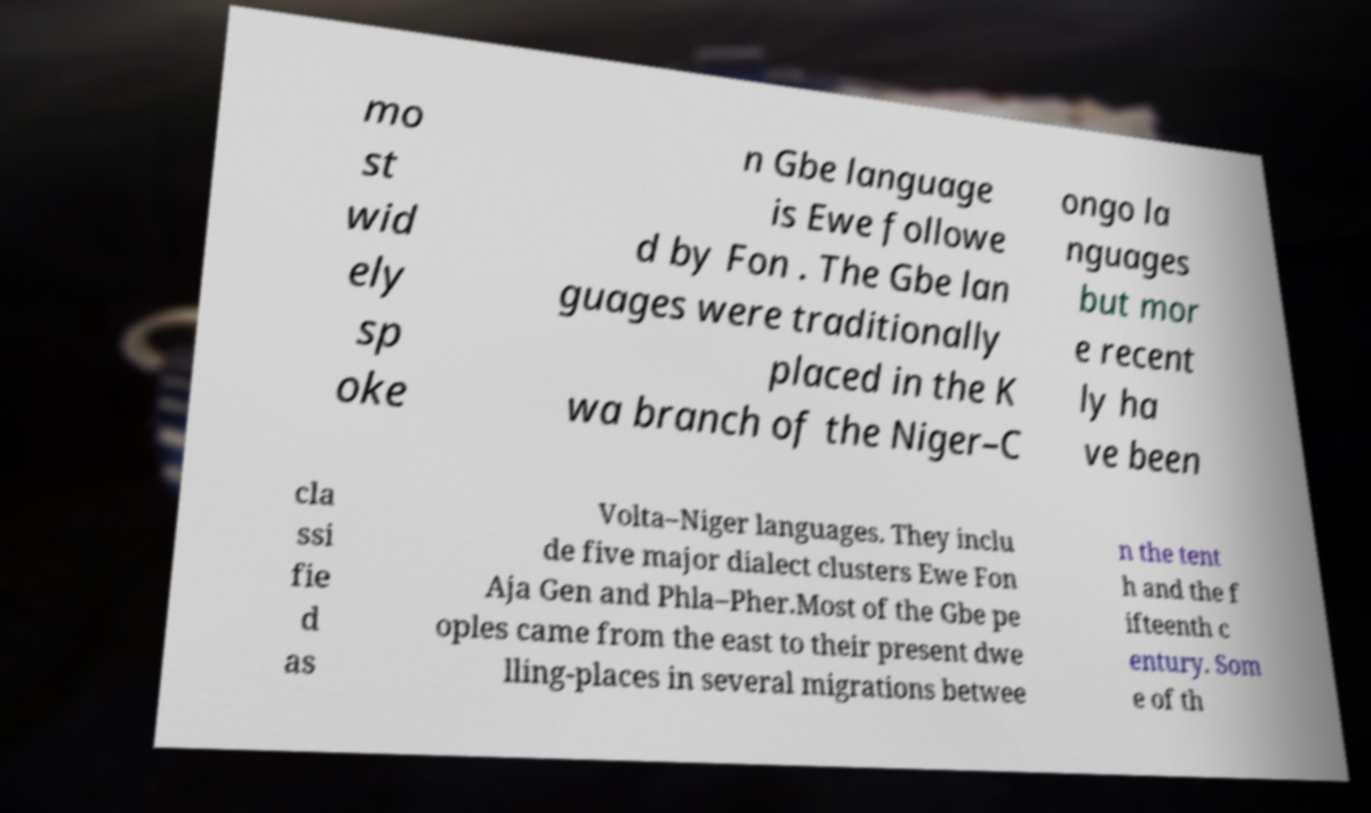What messages or text are displayed in this image? I need them in a readable, typed format. mo st wid ely sp oke n Gbe language is Ewe followe d by Fon . The Gbe lan guages were traditionally placed in the K wa branch of the Niger–C ongo la nguages but mor e recent ly ha ve been cla ssi fie d as Volta–Niger languages. They inclu de five major dialect clusters Ewe Fon Aja Gen and Phla–Pher.Most of the Gbe pe oples came from the east to their present dwe lling-places in several migrations betwee n the tent h and the f ifteenth c entury. Som e of th 